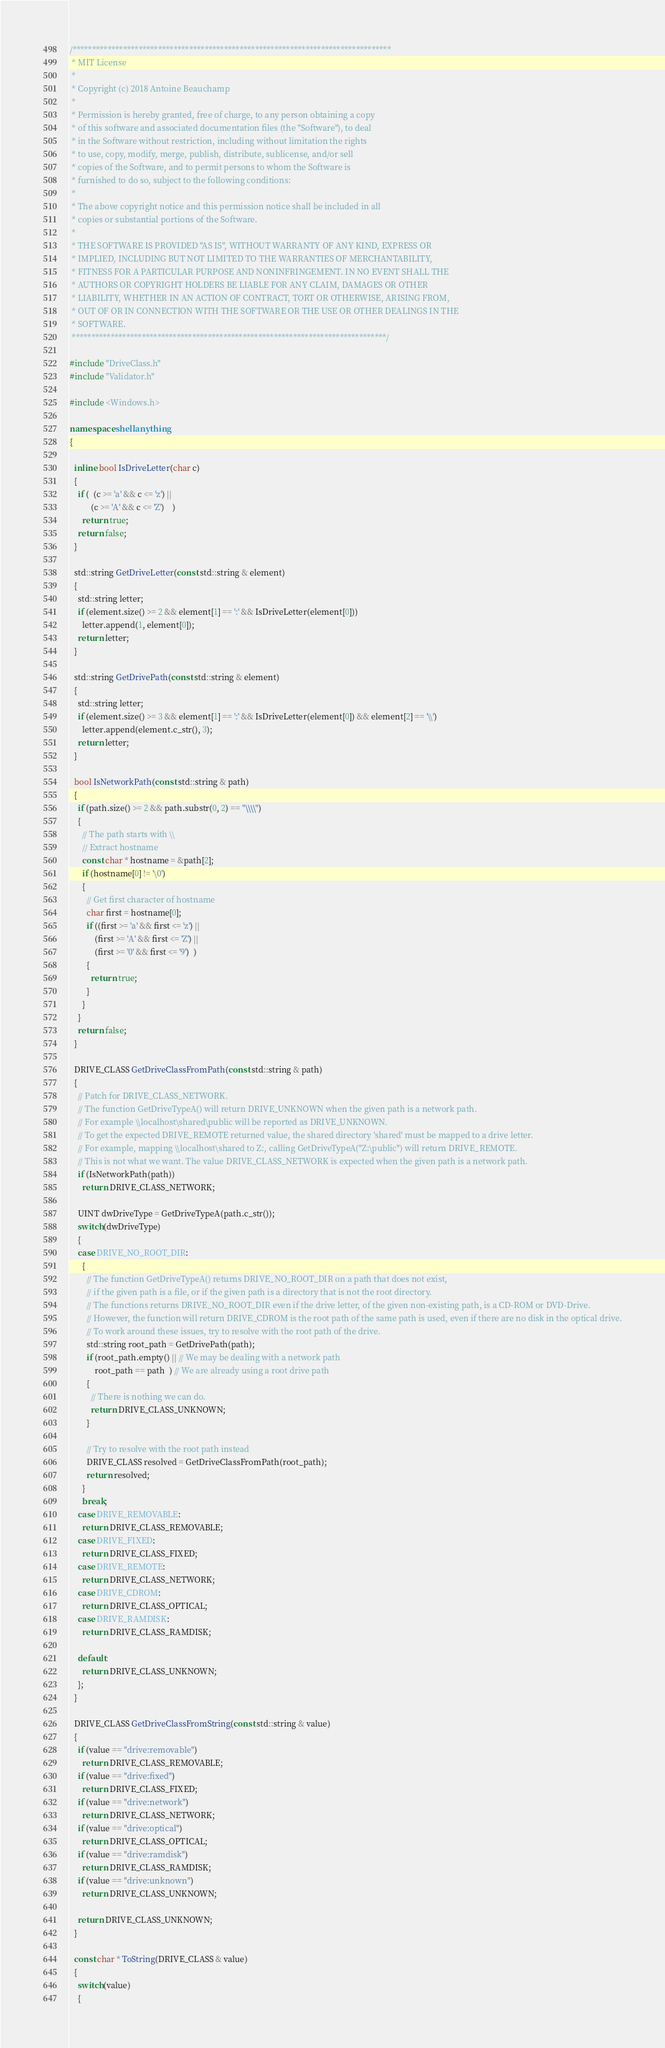<code> <loc_0><loc_0><loc_500><loc_500><_C++_>/**********************************************************************************
 * MIT License
 * 
 * Copyright (c) 2018 Antoine Beauchamp
 * 
 * Permission is hereby granted, free of charge, to any person obtaining a copy
 * of this software and associated documentation files (the "Software"), to deal
 * in the Software without restriction, including without limitation the rights
 * to use, copy, modify, merge, publish, distribute, sublicense, and/or sell
 * copies of the Software, and to permit persons to whom the Software is
 * furnished to do so, subject to the following conditions:
 * 
 * The above copyright notice and this permission notice shall be included in all
 * copies or substantial portions of the Software.
 * 
 * THE SOFTWARE IS PROVIDED "AS IS", WITHOUT WARRANTY OF ANY KIND, EXPRESS OR
 * IMPLIED, INCLUDING BUT NOT LIMITED TO THE WARRANTIES OF MERCHANTABILITY,
 * FITNESS FOR A PARTICULAR PURPOSE AND NONINFRINGEMENT. IN NO EVENT SHALL THE
 * AUTHORS OR COPYRIGHT HOLDERS BE LIABLE FOR ANY CLAIM, DAMAGES OR OTHER
 * LIABILITY, WHETHER IN AN ACTION OF CONTRACT, TORT OR OTHERWISE, ARISING FROM,
 * OUT OF OR IN CONNECTION WITH THE SOFTWARE OR THE USE OR OTHER DEALINGS IN THE
 * SOFTWARE.
 *********************************************************************************/

#include "DriveClass.h"
#include "Validator.h"

#include <Windows.h>

namespace shellanything
{

  inline bool IsDriveLetter(char c)
  {
    if (  (c >= 'a' && c <= 'z') ||
          (c >= 'A' && c <= 'Z')    )
      return true;
    return false;
  }

  std::string GetDriveLetter(const std::string & element)
  {
    std::string letter;
    if (element.size() >= 2 && element[1] == ':' && IsDriveLetter(element[0]))
      letter.append(1, element[0]);
    return letter;
  }

  std::string GetDrivePath(const std::string & element)
  {
    std::string letter;
    if (element.size() >= 3 && element[1] == ':' && IsDriveLetter(element[0]) && element[2] == '\\')
      letter.append(element.c_str(), 3);
    return letter;
  }

  bool IsNetworkPath(const std::string & path)
  {
    if (path.size() >= 2 && path.substr(0, 2) == "\\\\")
    {
      // The path starts with \\
      // Extract hostname
      const char * hostname = &path[2];
      if (hostname[0] != '\0')
      {
        // Get first character of hostname
        char first = hostname[0];
        if ((first >= 'a' && first <= 'z') ||
            (first >= 'A' && first <= 'Z') ||
            (first >= '0' && first <= '9')  )
        {
          return true;
        }
      }
    }
    return false;
  }

  DRIVE_CLASS GetDriveClassFromPath(const std::string & path)
  {
    // Patch for DRIVE_CLASS_NETWORK.
    // The function GetDriveTypeA() will return DRIVE_UNKNOWN when the given path is a network path.
    // For example \\localhost\shared\public will be reported as DRIVE_UNKNOWN.
    // To get the expected DRIVE_REMOTE returned value, the shared directory 'shared' must be mapped to a drive letter.
    // For example, mapping \\localhost\shared to Z:, calling GetDriveTypeA("Z:\public") will return DRIVE_REMOTE.
    // This is not what we want. The value DRIVE_CLASS_NETWORK is expected when the given path is a network path.
    if (IsNetworkPath(path))
      return DRIVE_CLASS_NETWORK;

    UINT dwDriveType = GetDriveTypeA(path.c_str());
    switch(dwDriveType)
    {
    case DRIVE_NO_ROOT_DIR:
      {
        // The function GetDriveTypeA() returns DRIVE_NO_ROOT_DIR on a path that does not exist,
        // if the given path is a file, or if the given path is a directory that is not the root directory.
        // The functions returns DRIVE_NO_ROOT_DIR even if the drive letter, of the given non-existing path, is a CD-ROM or DVD-Drive.
        // However, the function will return DRIVE_CDROM is the root path of the same path is used, even if there are no disk in the optical drive.
        // To work around these issues, try to resolve with the root path of the drive.
        std::string root_path = GetDrivePath(path);
        if (root_path.empty() || // We may be dealing with a network path
            root_path == path  ) // We are already using a root drive path
        {
          // There is nothing we can do.
          return DRIVE_CLASS_UNKNOWN;
        }
        
        // Try to resolve with the root path instead
        DRIVE_CLASS resolved = GetDriveClassFromPath(root_path);
        return resolved;
      }
      break;
    case DRIVE_REMOVABLE:
      return DRIVE_CLASS_REMOVABLE;
    case DRIVE_FIXED:
      return DRIVE_CLASS_FIXED;
    case DRIVE_REMOTE:
      return DRIVE_CLASS_NETWORK;
    case DRIVE_CDROM:
      return DRIVE_CLASS_OPTICAL;
    case DRIVE_RAMDISK:
      return DRIVE_CLASS_RAMDISK;

    default:
      return DRIVE_CLASS_UNKNOWN;
    };
  }

  DRIVE_CLASS GetDriveClassFromString(const std::string & value)
  {
    if (value == "drive:removable")
      return DRIVE_CLASS_REMOVABLE;
    if (value == "drive:fixed")
      return DRIVE_CLASS_FIXED;
    if (value == "drive:network")
      return DRIVE_CLASS_NETWORK;
    if (value == "drive:optical")
      return DRIVE_CLASS_OPTICAL;
    if (value == "drive:ramdisk")
      return DRIVE_CLASS_RAMDISK;
    if (value == "drive:unknown")
      return DRIVE_CLASS_UNKNOWN;

    return DRIVE_CLASS_UNKNOWN;
  }

  const char * ToString(DRIVE_CLASS & value)
  {
    switch(value)
    {</code> 